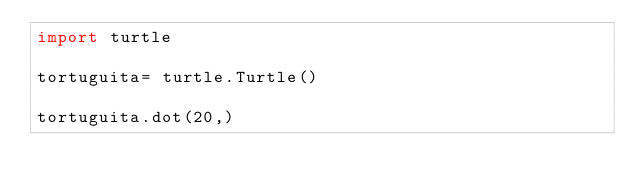Convert code to text. <code><loc_0><loc_0><loc_500><loc_500><_Python_>import turtle

tortuguita= turtle.Turtle()

tortuguita.dot(20,)</code> 